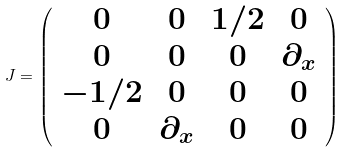<formula> <loc_0><loc_0><loc_500><loc_500>J = \left ( \begin{array} { c c c c } 0 & 0 & 1 / 2 & 0 \\ 0 & 0 & 0 & \partial _ { x } \\ - 1 / 2 & 0 & 0 & 0 \\ 0 & \partial _ { x } & 0 & 0 \end{array} \right )</formula> 